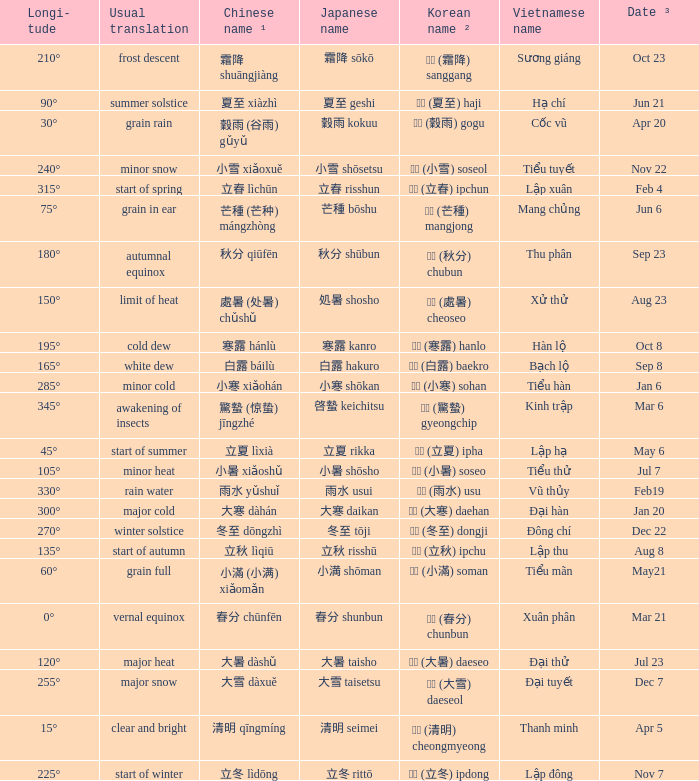WHICH Vietnamese name has a Chinese name ¹ of 芒種 (芒种) mángzhòng? Mang chủng. 